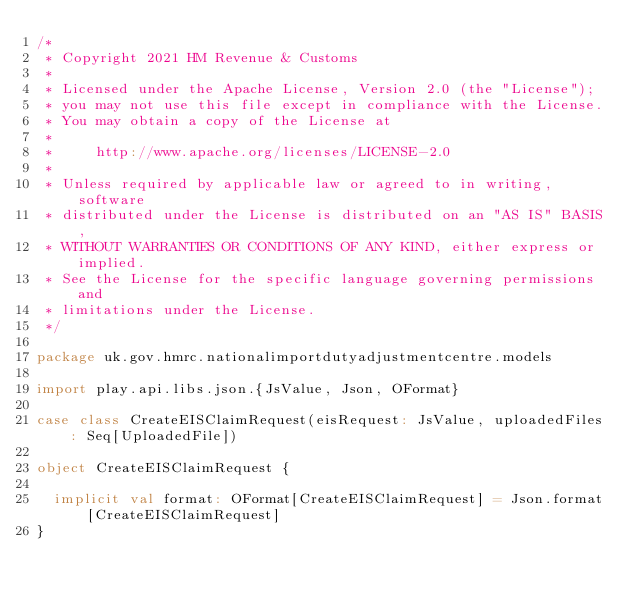<code> <loc_0><loc_0><loc_500><loc_500><_Scala_>/*
 * Copyright 2021 HM Revenue & Customs
 *
 * Licensed under the Apache License, Version 2.0 (the "License");
 * you may not use this file except in compliance with the License.
 * You may obtain a copy of the License at
 *
 *     http://www.apache.org/licenses/LICENSE-2.0
 *
 * Unless required by applicable law or agreed to in writing, software
 * distributed under the License is distributed on an "AS IS" BASIS,
 * WITHOUT WARRANTIES OR CONDITIONS OF ANY KIND, either express or implied.
 * See the License for the specific language governing permissions and
 * limitations under the License.
 */

package uk.gov.hmrc.nationalimportdutyadjustmentcentre.models

import play.api.libs.json.{JsValue, Json, OFormat}

case class CreateEISClaimRequest(eisRequest: JsValue, uploadedFiles: Seq[UploadedFile])

object CreateEISClaimRequest {

  implicit val format: OFormat[CreateEISClaimRequest] = Json.format[CreateEISClaimRequest]
}
</code> 